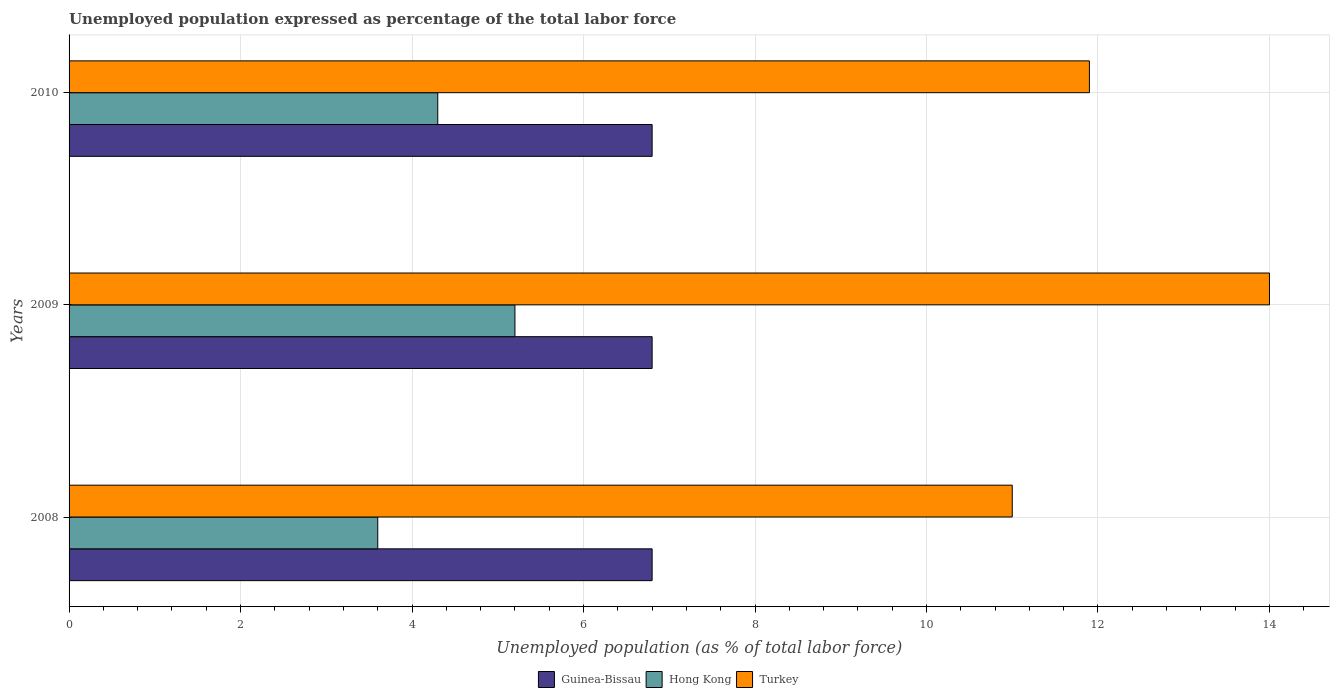How many bars are there on the 1st tick from the bottom?
Ensure brevity in your answer.  3. What is the label of the 1st group of bars from the top?
Provide a succinct answer. 2010. In how many cases, is the number of bars for a given year not equal to the number of legend labels?
Offer a very short reply. 0. What is the unemployment in in Turkey in 2010?
Offer a terse response. 11.9. Across all years, what is the maximum unemployment in in Hong Kong?
Keep it short and to the point. 5.2. Across all years, what is the minimum unemployment in in Hong Kong?
Your response must be concise. 3.6. In which year was the unemployment in in Hong Kong minimum?
Your answer should be very brief. 2008. What is the total unemployment in in Turkey in the graph?
Provide a succinct answer. 36.9. What is the difference between the unemployment in in Hong Kong in 2009 and that in 2010?
Offer a very short reply. 0.9. What is the difference between the unemployment in in Hong Kong in 2010 and the unemployment in in Guinea-Bissau in 2009?
Ensure brevity in your answer.  -2.5. What is the average unemployment in in Guinea-Bissau per year?
Keep it short and to the point. 6.8. In the year 2010, what is the difference between the unemployment in in Turkey and unemployment in in Guinea-Bissau?
Your response must be concise. 5.1. In how many years, is the unemployment in in Hong Kong greater than 2.8 %?
Your answer should be compact. 3. What is the difference between the highest and the second highest unemployment in in Hong Kong?
Give a very brief answer. 0.9. Is the sum of the unemployment in in Turkey in 2008 and 2009 greater than the maximum unemployment in in Hong Kong across all years?
Ensure brevity in your answer.  Yes. What does the 1st bar from the bottom in 2008 represents?
Offer a terse response. Guinea-Bissau. Is it the case that in every year, the sum of the unemployment in in Guinea-Bissau and unemployment in in Hong Kong is greater than the unemployment in in Turkey?
Your answer should be compact. No. How many bars are there?
Make the answer very short. 9. Are the values on the major ticks of X-axis written in scientific E-notation?
Provide a short and direct response. No. Does the graph contain any zero values?
Your response must be concise. No. Does the graph contain grids?
Provide a succinct answer. Yes. Where does the legend appear in the graph?
Offer a terse response. Bottom center. What is the title of the graph?
Make the answer very short. Unemployed population expressed as percentage of the total labor force. What is the label or title of the X-axis?
Your response must be concise. Unemployed population (as % of total labor force). What is the Unemployed population (as % of total labor force) in Guinea-Bissau in 2008?
Your answer should be compact. 6.8. What is the Unemployed population (as % of total labor force) of Hong Kong in 2008?
Your response must be concise. 3.6. What is the Unemployed population (as % of total labor force) of Guinea-Bissau in 2009?
Offer a terse response. 6.8. What is the Unemployed population (as % of total labor force) of Hong Kong in 2009?
Your answer should be very brief. 5.2. What is the Unemployed population (as % of total labor force) in Guinea-Bissau in 2010?
Ensure brevity in your answer.  6.8. What is the Unemployed population (as % of total labor force) in Hong Kong in 2010?
Your answer should be very brief. 4.3. What is the Unemployed population (as % of total labor force) in Turkey in 2010?
Provide a succinct answer. 11.9. Across all years, what is the maximum Unemployed population (as % of total labor force) in Guinea-Bissau?
Offer a terse response. 6.8. Across all years, what is the maximum Unemployed population (as % of total labor force) in Hong Kong?
Your answer should be very brief. 5.2. Across all years, what is the minimum Unemployed population (as % of total labor force) of Guinea-Bissau?
Your response must be concise. 6.8. Across all years, what is the minimum Unemployed population (as % of total labor force) in Hong Kong?
Offer a very short reply. 3.6. Across all years, what is the minimum Unemployed population (as % of total labor force) of Turkey?
Your answer should be very brief. 11. What is the total Unemployed population (as % of total labor force) in Guinea-Bissau in the graph?
Ensure brevity in your answer.  20.4. What is the total Unemployed population (as % of total labor force) of Hong Kong in the graph?
Provide a succinct answer. 13.1. What is the total Unemployed population (as % of total labor force) of Turkey in the graph?
Keep it short and to the point. 36.9. What is the difference between the Unemployed population (as % of total labor force) of Guinea-Bissau in 2008 and that in 2010?
Your response must be concise. 0. What is the difference between the Unemployed population (as % of total labor force) in Hong Kong in 2008 and that in 2010?
Offer a terse response. -0.7. What is the difference between the Unemployed population (as % of total labor force) in Turkey in 2008 and that in 2010?
Offer a terse response. -0.9. What is the difference between the Unemployed population (as % of total labor force) in Guinea-Bissau in 2008 and the Unemployed population (as % of total labor force) in Hong Kong in 2009?
Ensure brevity in your answer.  1.6. What is the difference between the Unemployed population (as % of total labor force) of Hong Kong in 2008 and the Unemployed population (as % of total labor force) of Turkey in 2009?
Your answer should be compact. -10.4. What is the difference between the Unemployed population (as % of total labor force) of Guinea-Bissau in 2008 and the Unemployed population (as % of total labor force) of Hong Kong in 2010?
Make the answer very short. 2.5. What is the difference between the Unemployed population (as % of total labor force) of Guinea-Bissau in 2008 and the Unemployed population (as % of total labor force) of Turkey in 2010?
Your answer should be very brief. -5.1. What is the difference between the Unemployed population (as % of total labor force) in Hong Kong in 2008 and the Unemployed population (as % of total labor force) in Turkey in 2010?
Offer a very short reply. -8.3. What is the difference between the Unemployed population (as % of total labor force) in Guinea-Bissau in 2009 and the Unemployed population (as % of total labor force) in Hong Kong in 2010?
Provide a succinct answer. 2.5. What is the difference between the Unemployed population (as % of total labor force) in Guinea-Bissau in 2009 and the Unemployed population (as % of total labor force) in Turkey in 2010?
Your response must be concise. -5.1. What is the average Unemployed population (as % of total labor force) in Guinea-Bissau per year?
Ensure brevity in your answer.  6.8. What is the average Unemployed population (as % of total labor force) of Hong Kong per year?
Give a very brief answer. 4.37. In the year 2008, what is the difference between the Unemployed population (as % of total labor force) of Guinea-Bissau and Unemployed population (as % of total labor force) of Hong Kong?
Ensure brevity in your answer.  3.2. In the year 2008, what is the difference between the Unemployed population (as % of total labor force) of Hong Kong and Unemployed population (as % of total labor force) of Turkey?
Your answer should be very brief. -7.4. In the year 2010, what is the difference between the Unemployed population (as % of total labor force) in Hong Kong and Unemployed population (as % of total labor force) in Turkey?
Make the answer very short. -7.6. What is the ratio of the Unemployed population (as % of total labor force) in Hong Kong in 2008 to that in 2009?
Keep it short and to the point. 0.69. What is the ratio of the Unemployed population (as % of total labor force) of Turkey in 2008 to that in 2009?
Give a very brief answer. 0.79. What is the ratio of the Unemployed population (as % of total labor force) of Hong Kong in 2008 to that in 2010?
Offer a terse response. 0.84. What is the ratio of the Unemployed population (as % of total labor force) of Turkey in 2008 to that in 2010?
Make the answer very short. 0.92. What is the ratio of the Unemployed population (as % of total labor force) in Hong Kong in 2009 to that in 2010?
Keep it short and to the point. 1.21. What is the ratio of the Unemployed population (as % of total labor force) of Turkey in 2009 to that in 2010?
Give a very brief answer. 1.18. 